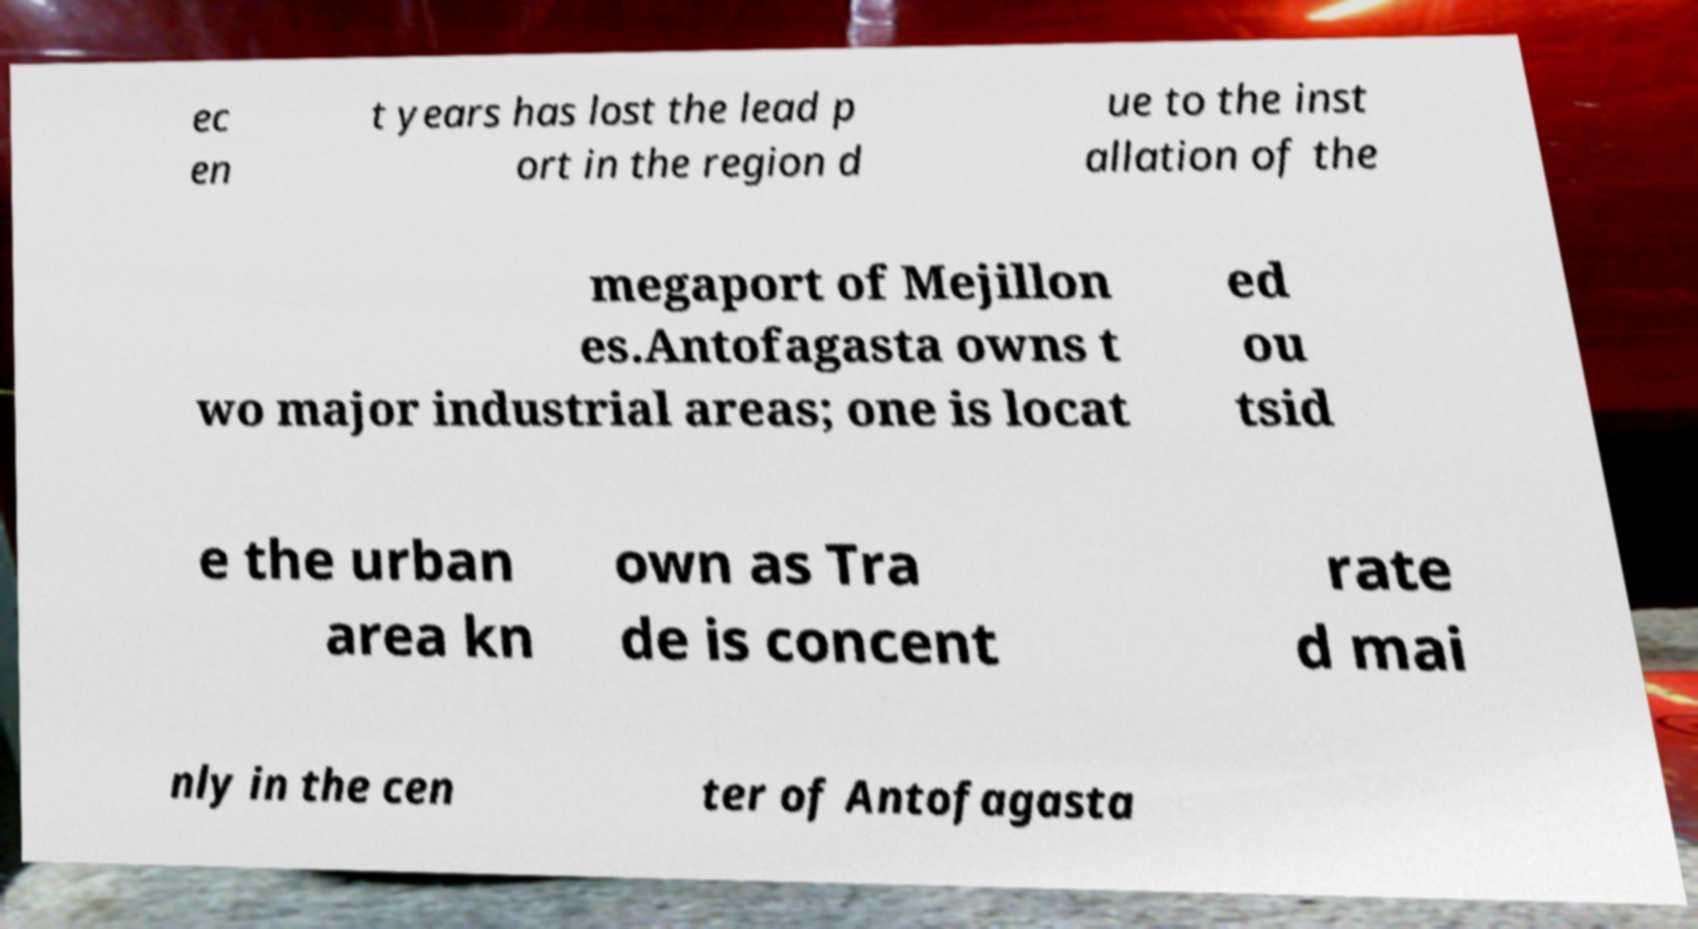Can you read and provide the text displayed in the image?This photo seems to have some interesting text. Can you extract and type it out for me? ec en t years has lost the lead p ort in the region d ue to the inst allation of the megaport of Mejillon es.Antofagasta owns t wo major industrial areas; one is locat ed ou tsid e the urban area kn own as Tra de is concent rate d mai nly in the cen ter of Antofagasta 